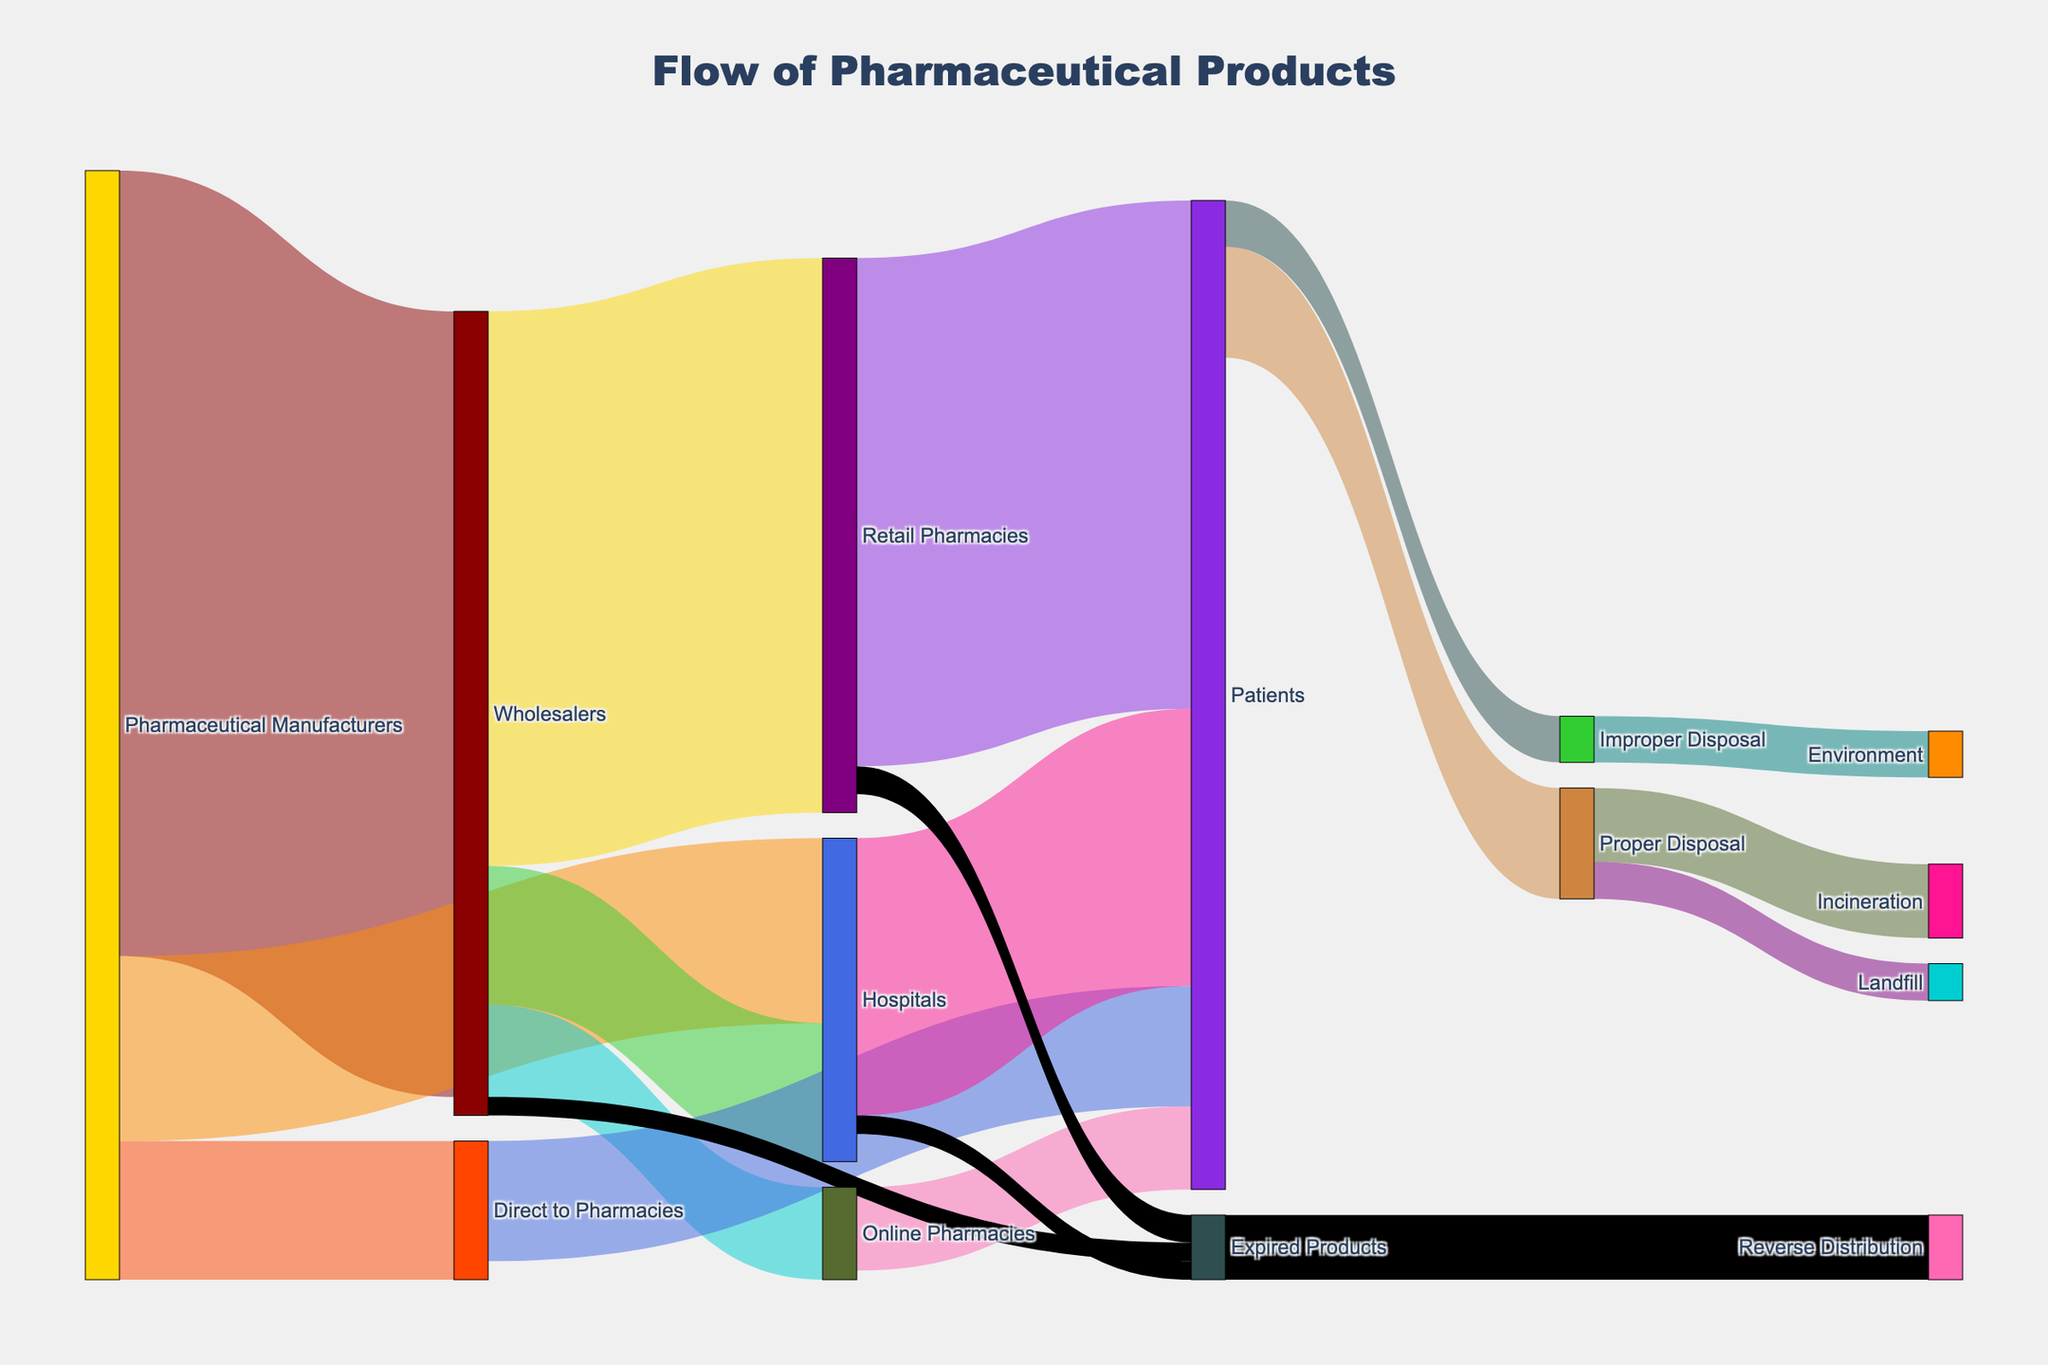what is the largest flow from Pharmaceutical Manufacturers? The largest flow from Pharmaceutical Manufacturers is the one with the highest value among its direct connections. Comparing 850 (to Wholesalers), 150 (to Direct to Pharmacies), and 200 (to Hospitals), 850 is the largest.
Answer: Wholesalers How much pharmaceutical product flows directly to Pharmacies and Hospitals combined from Manufacturers? Sum the values of flows from Manufacturers to Pharmacies (150) and Hospitals (200). 150 + 200 = 350
Answer: 350 What is the flow value from Wholesalers that results in pharmaceutical products reaching Patients via Retail Pharmacies? The flow from Wholesalers to Retail Pharmacies is 600, which eventually reaches Patients via Retail Pharmacies.
Answer: 600 How does the flow of products from Online Pharmacies to Patients compare with Direct to Pharmacies to Patients? Comparing the values: Online Pharmacies to Patients is 90, and Direct to Pharmacies to Patients is 130. 130 is greater than 90.
Answer: Direct to Pharmacies to Patients is greater What is the total value of expired products flowing back into the system through Reverse Distribution? Summing all the expired products from Wholesalers (20), Retail Pharmacies (30), and Hospitals (20) gives 70.
Answer: 70 What percentage of Patients’ product is properly disposed of? From Patients, 120 goes to Proper Disposal and 50 to Improper Disposal. The total is 120 + 50 = 170. The percentage is (120 / 170) * 100 ≈ 70.59%.
Answer: Approximately 70.59% Which flows show the movement of products into the environment due to improper disposal? The flow from Improper Disposal to Environment shows the product movement due to improper disposal.
Answer: Improper Disposal to Environment Is there any flow from Retail Pharmacies that does not reach Patients or result in expired products? All flows from Retail Pharmacies either go to Patients (550) or Expired Products (30). There are no other flows.
Answer: No What is the final destination of the improperly disposed pharmaceutical products? The only flow from Improper Disposal is to Environment, indicating it as the final destination.
Answer: Environment 